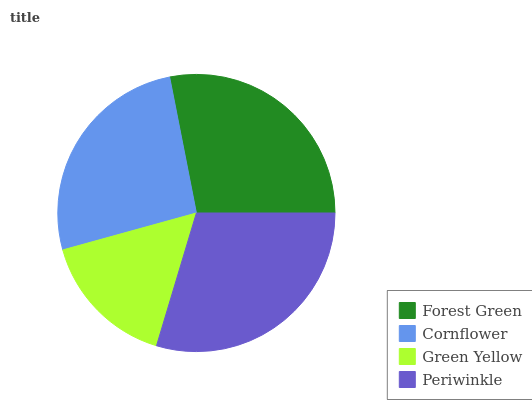Is Green Yellow the minimum?
Answer yes or no. Yes. Is Periwinkle the maximum?
Answer yes or no. Yes. Is Cornflower the minimum?
Answer yes or no. No. Is Cornflower the maximum?
Answer yes or no. No. Is Forest Green greater than Cornflower?
Answer yes or no. Yes. Is Cornflower less than Forest Green?
Answer yes or no. Yes. Is Cornflower greater than Forest Green?
Answer yes or no. No. Is Forest Green less than Cornflower?
Answer yes or no. No. Is Forest Green the high median?
Answer yes or no. Yes. Is Cornflower the low median?
Answer yes or no. Yes. Is Green Yellow the high median?
Answer yes or no. No. Is Periwinkle the low median?
Answer yes or no. No. 